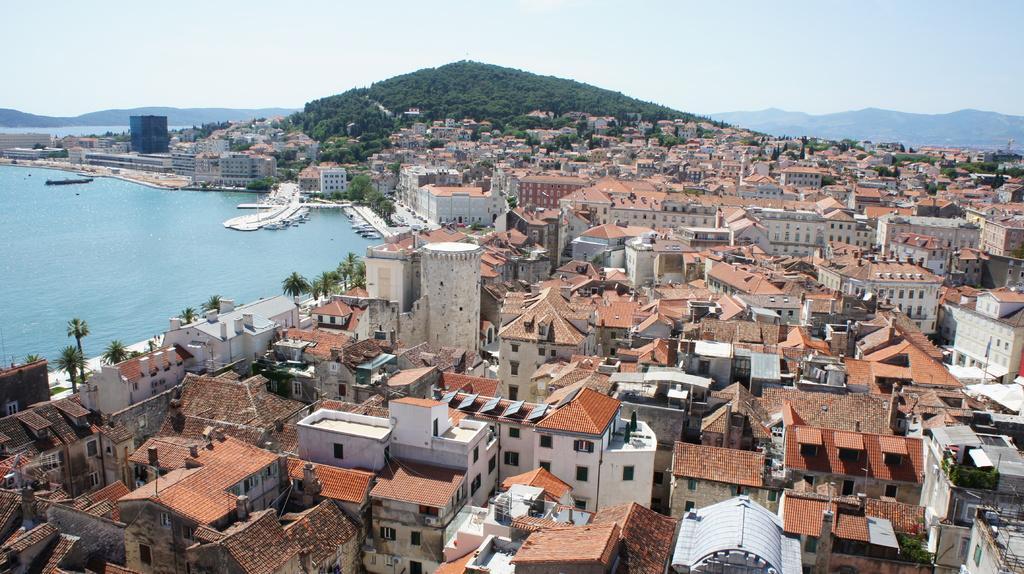Describe this image in one or two sentences. In this picture we can see few buildings and trees, and also we can find few boats in the water, in the background we can see hills. 